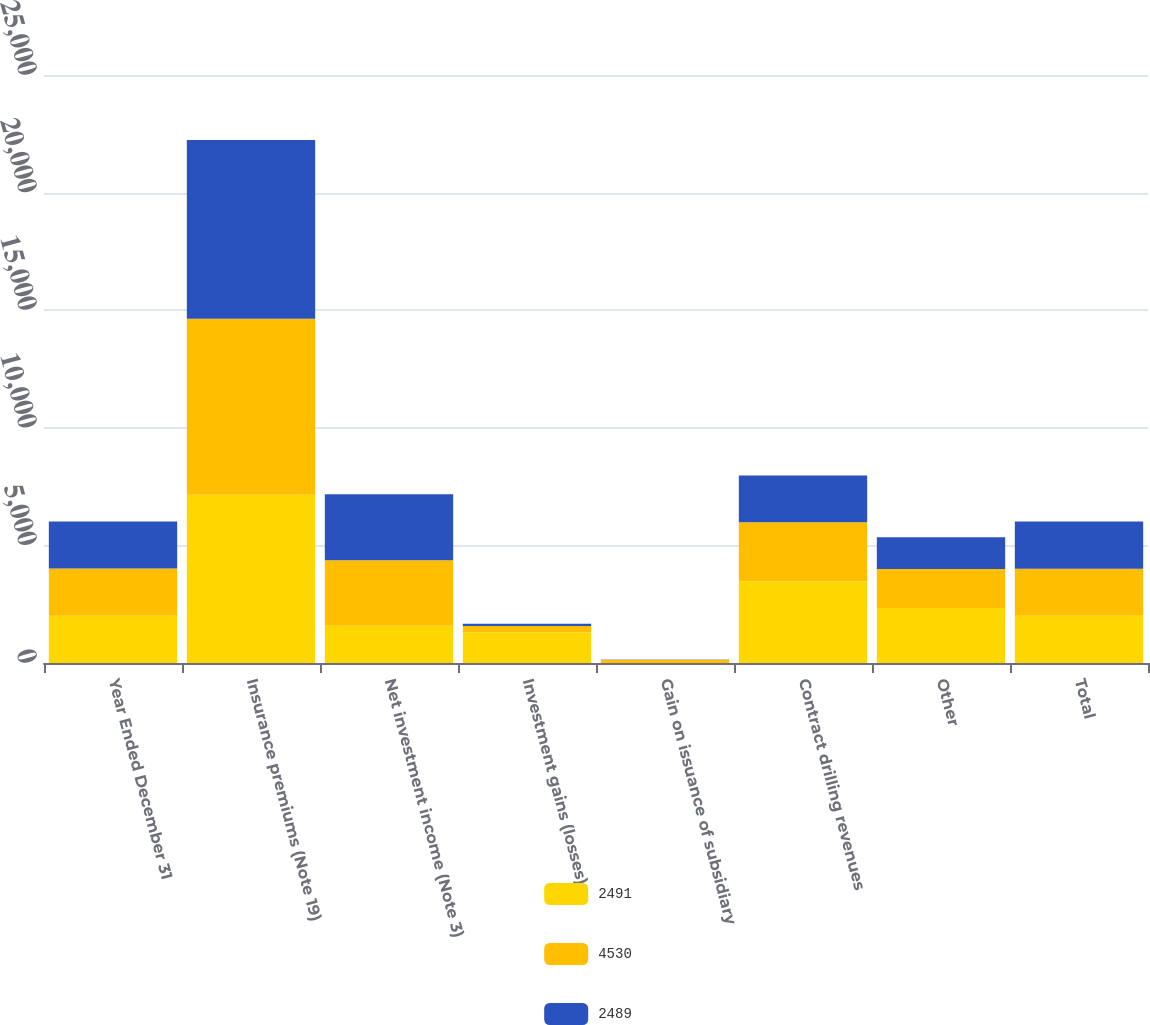Convert chart. <chart><loc_0><loc_0><loc_500><loc_500><stacked_bar_chart><ecel><fcel>Year Ended December 31<fcel>Insurance premiums (Note 19)<fcel>Net investment income (Note 3)<fcel>Investment gains (losses)<fcel>Gain on issuance of subsidiary<fcel>Contract drilling revenues<fcel>Other<fcel>Total<nl><fcel>2491<fcel>2008<fcel>7150<fcel>1581<fcel>1296<fcel>2<fcel>3476<fcel>2334<fcel>2006<nl><fcel>4530<fcel>2007<fcel>7482<fcel>2785<fcel>276<fcel>141<fcel>2506<fcel>1664<fcel>2006<nl><fcel>2489<fcel>2006<fcel>7603<fcel>2806<fcel>93<fcel>9<fcel>1987<fcel>1346<fcel>2006<nl></chart> 